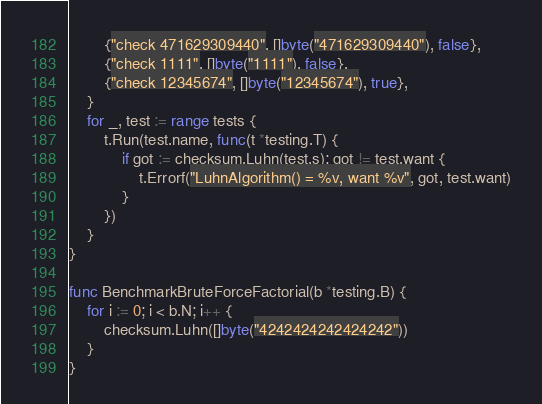Convert code to text. <code><loc_0><loc_0><loc_500><loc_500><_Go_>		{"check 471629309440", []byte("471629309440"), false},
		{"check 1111", []byte("1111"), false},
		{"check 12345674", []byte("12345674"), true},
	}
	for _, test := range tests {
		t.Run(test.name, func(t *testing.T) {
			if got := checksum.Luhn(test.s); got != test.want {
				t.Errorf("LuhnAlgorithm() = %v, want %v", got, test.want)
			}
		})
	}
}

func BenchmarkBruteForceFactorial(b *testing.B) {
	for i := 0; i < b.N; i++ {
		checksum.Luhn([]byte("4242424242424242"))
	}
}
</code> 